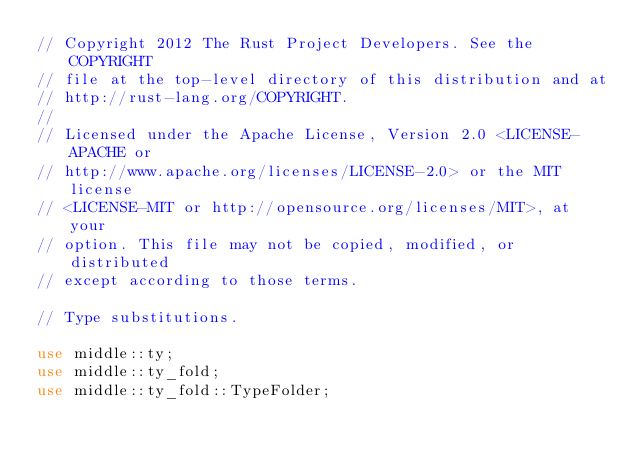<code> <loc_0><loc_0><loc_500><loc_500><_Rust_>// Copyright 2012 The Rust Project Developers. See the COPYRIGHT
// file at the top-level directory of this distribution and at
// http://rust-lang.org/COPYRIGHT.
//
// Licensed under the Apache License, Version 2.0 <LICENSE-APACHE or
// http://www.apache.org/licenses/LICENSE-2.0> or the MIT license
// <LICENSE-MIT or http://opensource.org/licenses/MIT>, at your
// option. This file may not be copied, modified, or distributed
// except according to those terms.

// Type substitutions.

use middle::ty;
use middle::ty_fold;
use middle::ty_fold::TypeFolder;</code> 